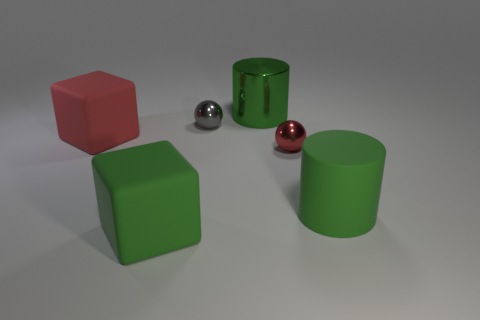What materials do these objects appear to be made from? The objects in the image appear to be made from rubber due to their matte texture and soft reflections, suggesting they have a non-metallic surface. How can you tell they are not metallic? Metal typically has a shinier surface with sharp reflections. The objects here have a diffused reflection that is characteristic of rubber or plastic materials. 